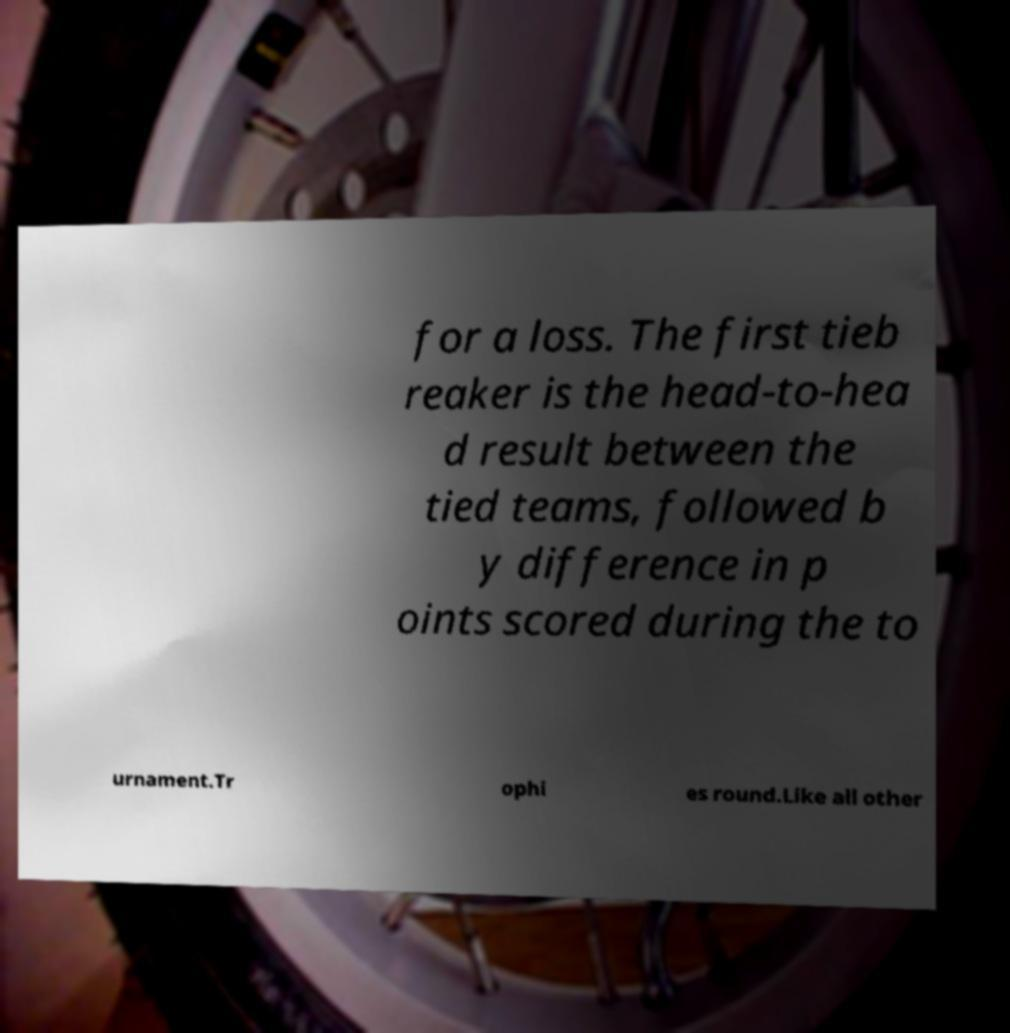Please read and relay the text visible in this image. What does it say? for a loss. The first tieb reaker is the head-to-hea d result between the tied teams, followed b y difference in p oints scored during the to urnament.Tr ophi es round.Like all other 